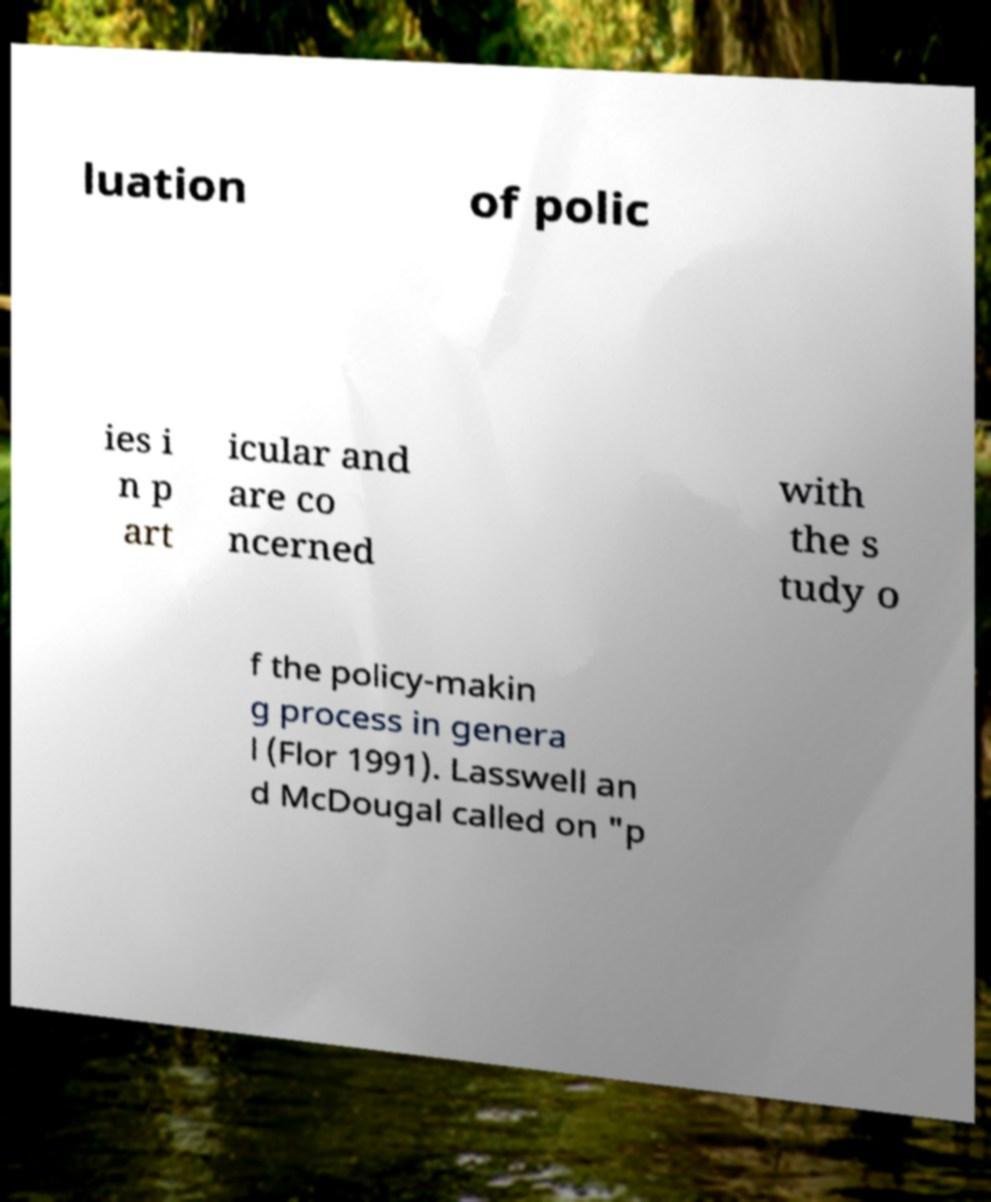Please identify and transcribe the text found in this image. luation of polic ies i n p art icular and are co ncerned with the s tudy o f the policy-makin g process in genera l (Flor 1991). Lasswell an d McDougal called on "p 